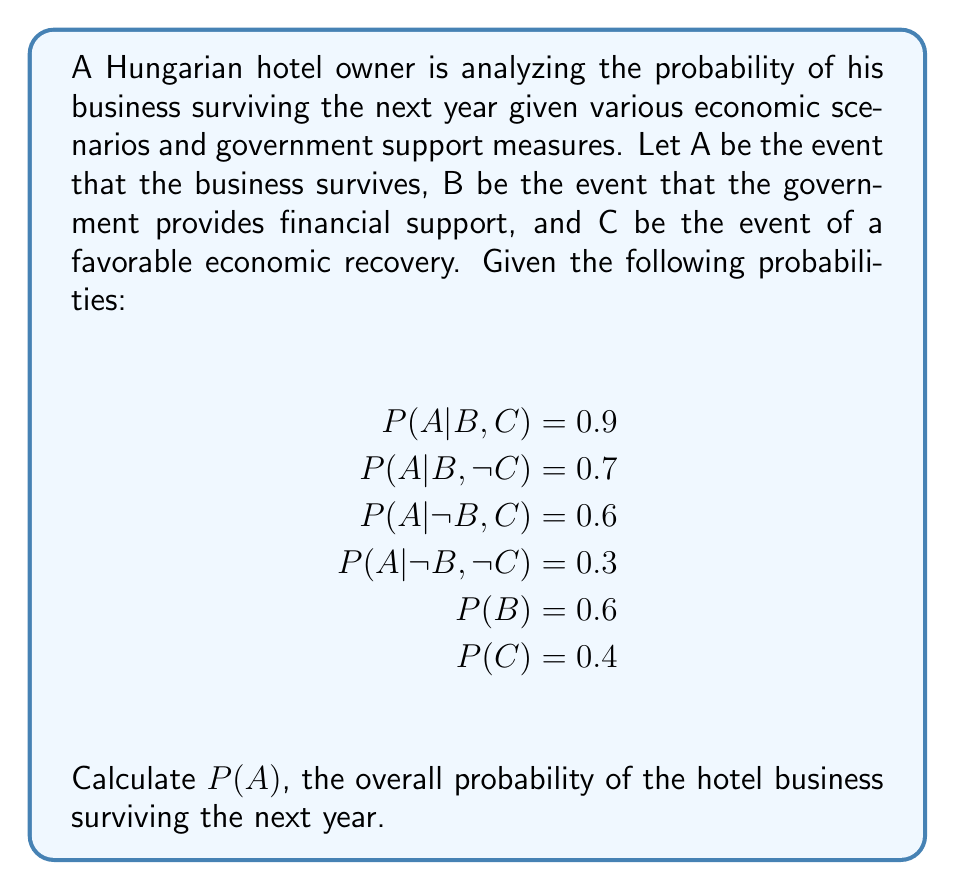Can you answer this question? To solve this problem, we'll use the law of total probability. We need to consider all possible combinations of events B and C:

1. First, let's list all possible scenarios:
   - B and C
   - B and not C
   - not B and C
   - not B and not C

2. We'll use the formula:
   $$P(A) = P(A|B,C)P(B)P(C) + P(A|B,\text{not }C)P(B)P(\text{not }C) + P(A|\text{not }B,C)P(\text{not }B)P(C) + P(A|\text{not }B,\text{not }C)P(\text{not }B)P(\text{not }C)$$

3. Calculate P(not B) and P(not C):
   $$P(\text{not }B) = 1 - P(B) = 1 - 0.6 = 0.4$$
   $$P(\text{not }C) = 1 - P(C) = 1 - 0.4 = 0.6$$

4. Now, let's substitute the values into the formula:
   $$P(A) = 0.9 \cdot 0.6 \cdot 0.4 + 0.7 \cdot 0.6 \cdot 0.6 + 0.6 \cdot 0.4 \cdot 0.4 + 0.3 \cdot 0.4 \cdot 0.6$$

5. Calculate each term:
   $$P(A) = 0.216 + 0.252 + 0.096 + 0.072$$

6. Sum up the terms:
   $$P(A) = 0.636$$

Therefore, the overall probability of the hotel business surviving the next year is 0.636 or 63.6%.
Answer: 0.636 